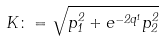<formula> <loc_0><loc_0><loc_500><loc_500>K \colon = \sqrt { p _ { 1 } ^ { 2 } + e ^ { - 2 q ^ { 1 } } p _ { 2 } ^ { 2 } }</formula> 